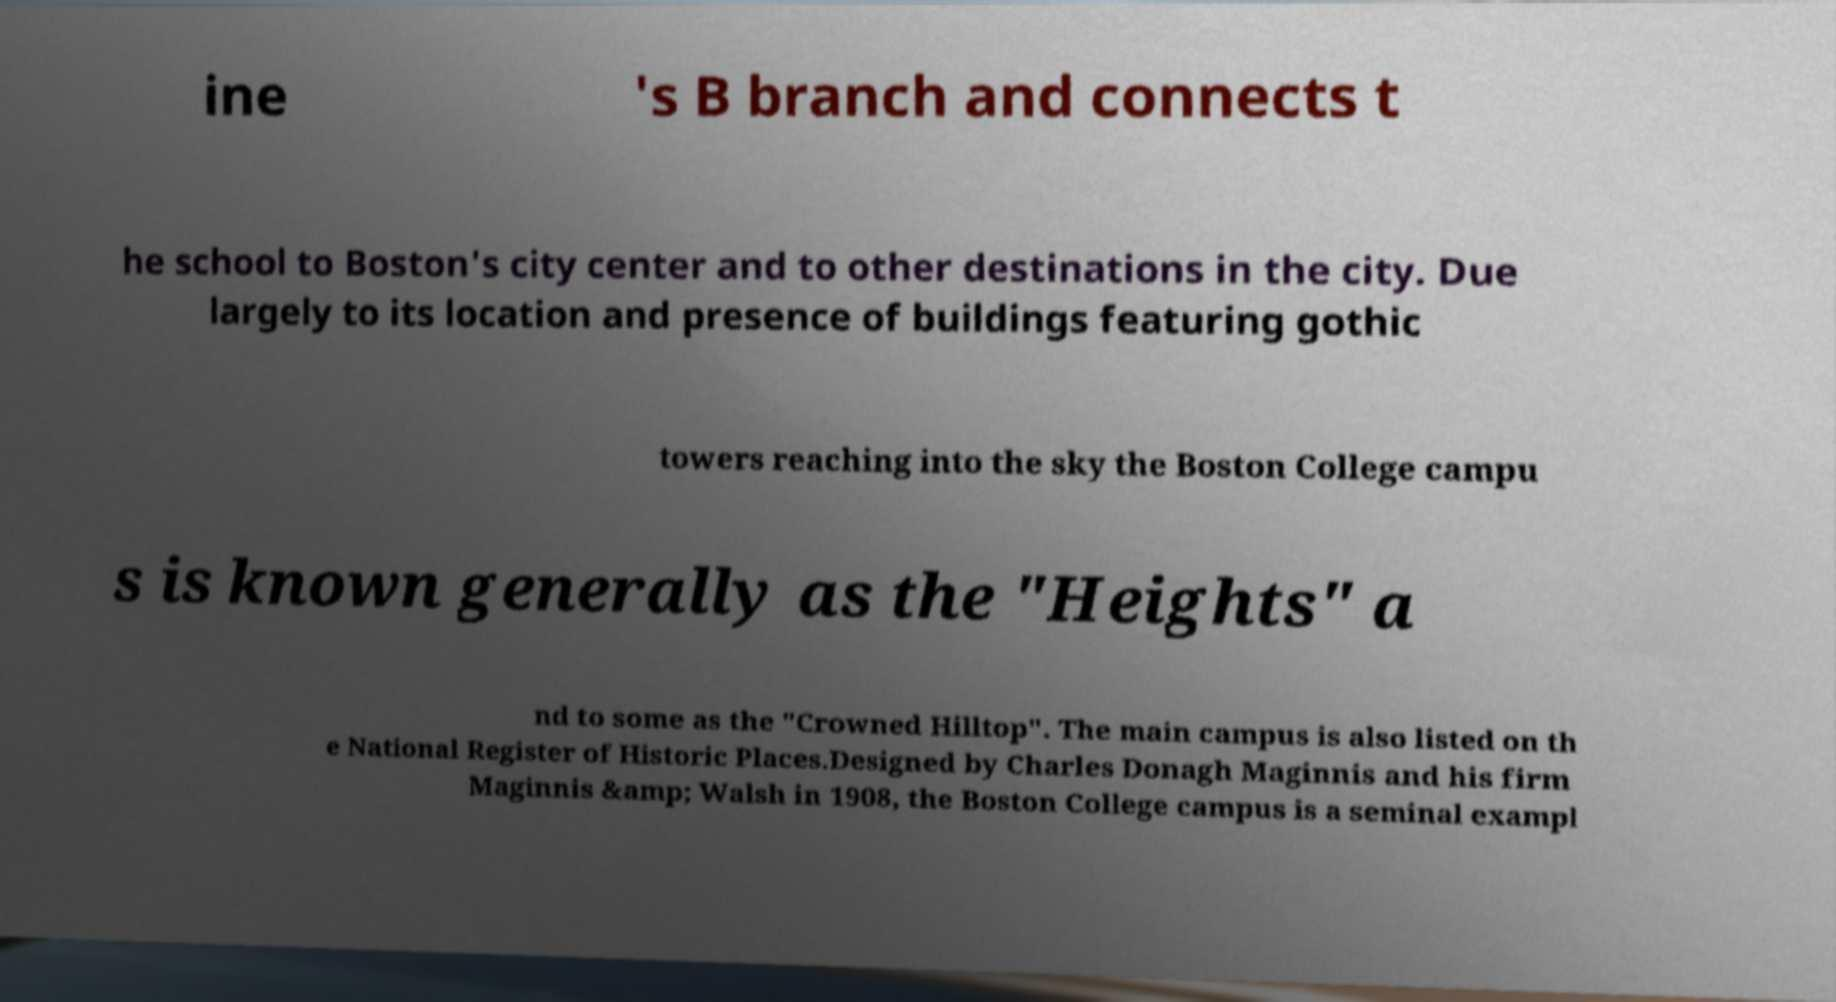Could you extract and type out the text from this image? ine 's B branch and connects t he school to Boston's city center and to other destinations in the city. Due largely to its location and presence of buildings featuring gothic towers reaching into the sky the Boston College campu s is known generally as the "Heights" a nd to some as the "Crowned Hilltop". The main campus is also listed on th e National Register of Historic Places.Designed by Charles Donagh Maginnis and his firm Maginnis &amp; Walsh in 1908, the Boston College campus is a seminal exampl 